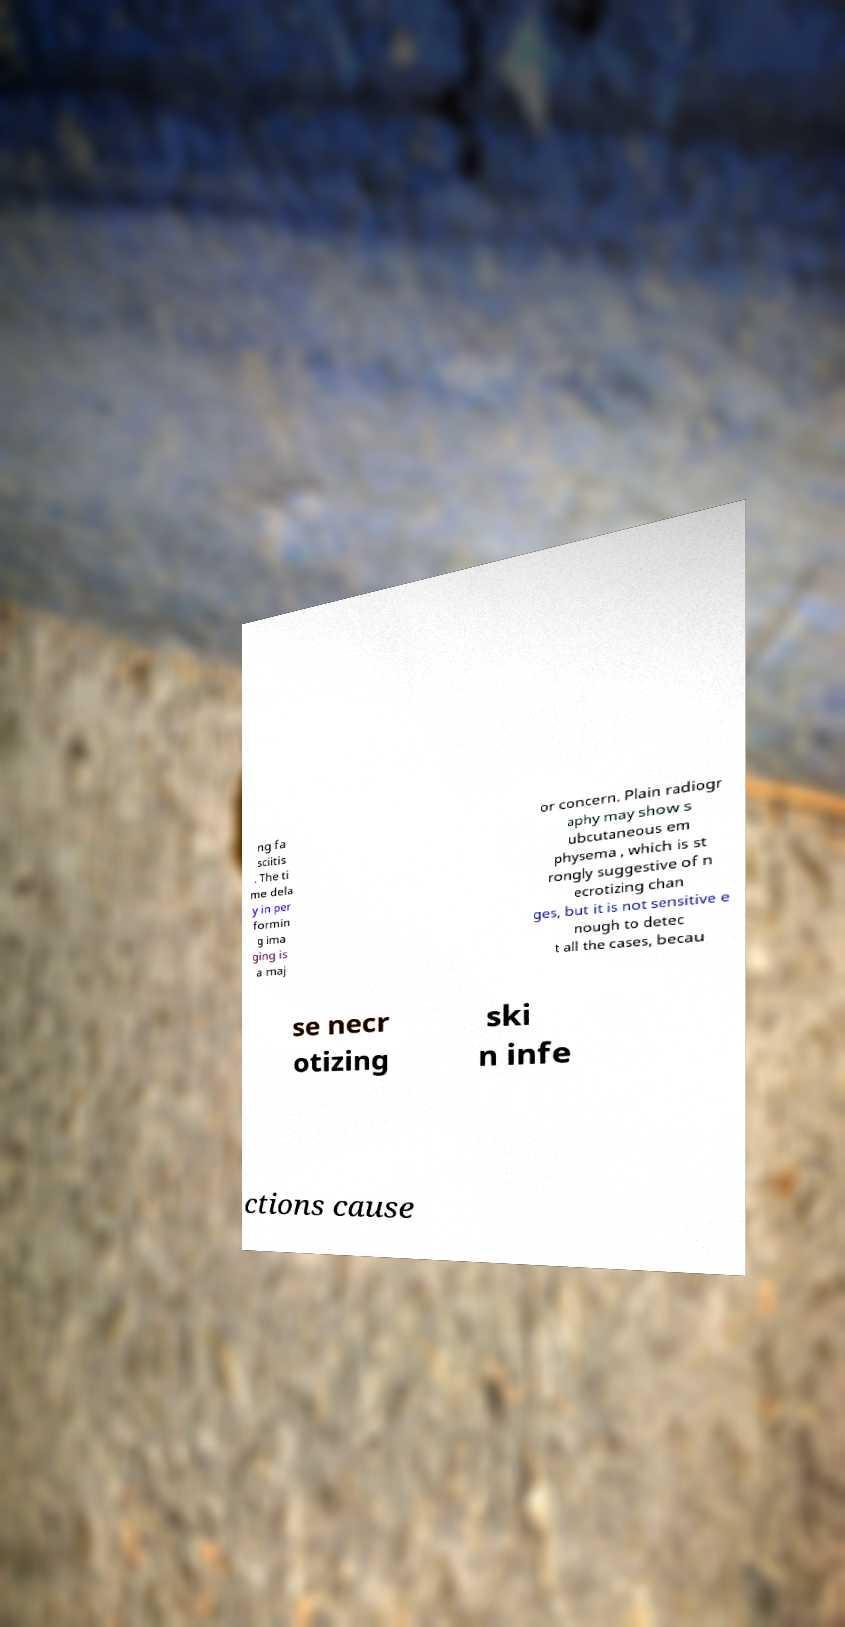For documentation purposes, I need the text within this image transcribed. Could you provide that? ng fa sciitis . The ti me dela y in per formin g ima ging is a maj or concern. Plain radiogr aphy may show s ubcutaneous em physema , which is st rongly suggestive of n ecrotizing chan ges, but it is not sensitive e nough to detec t all the cases, becau se necr otizing ski n infe ctions cause 